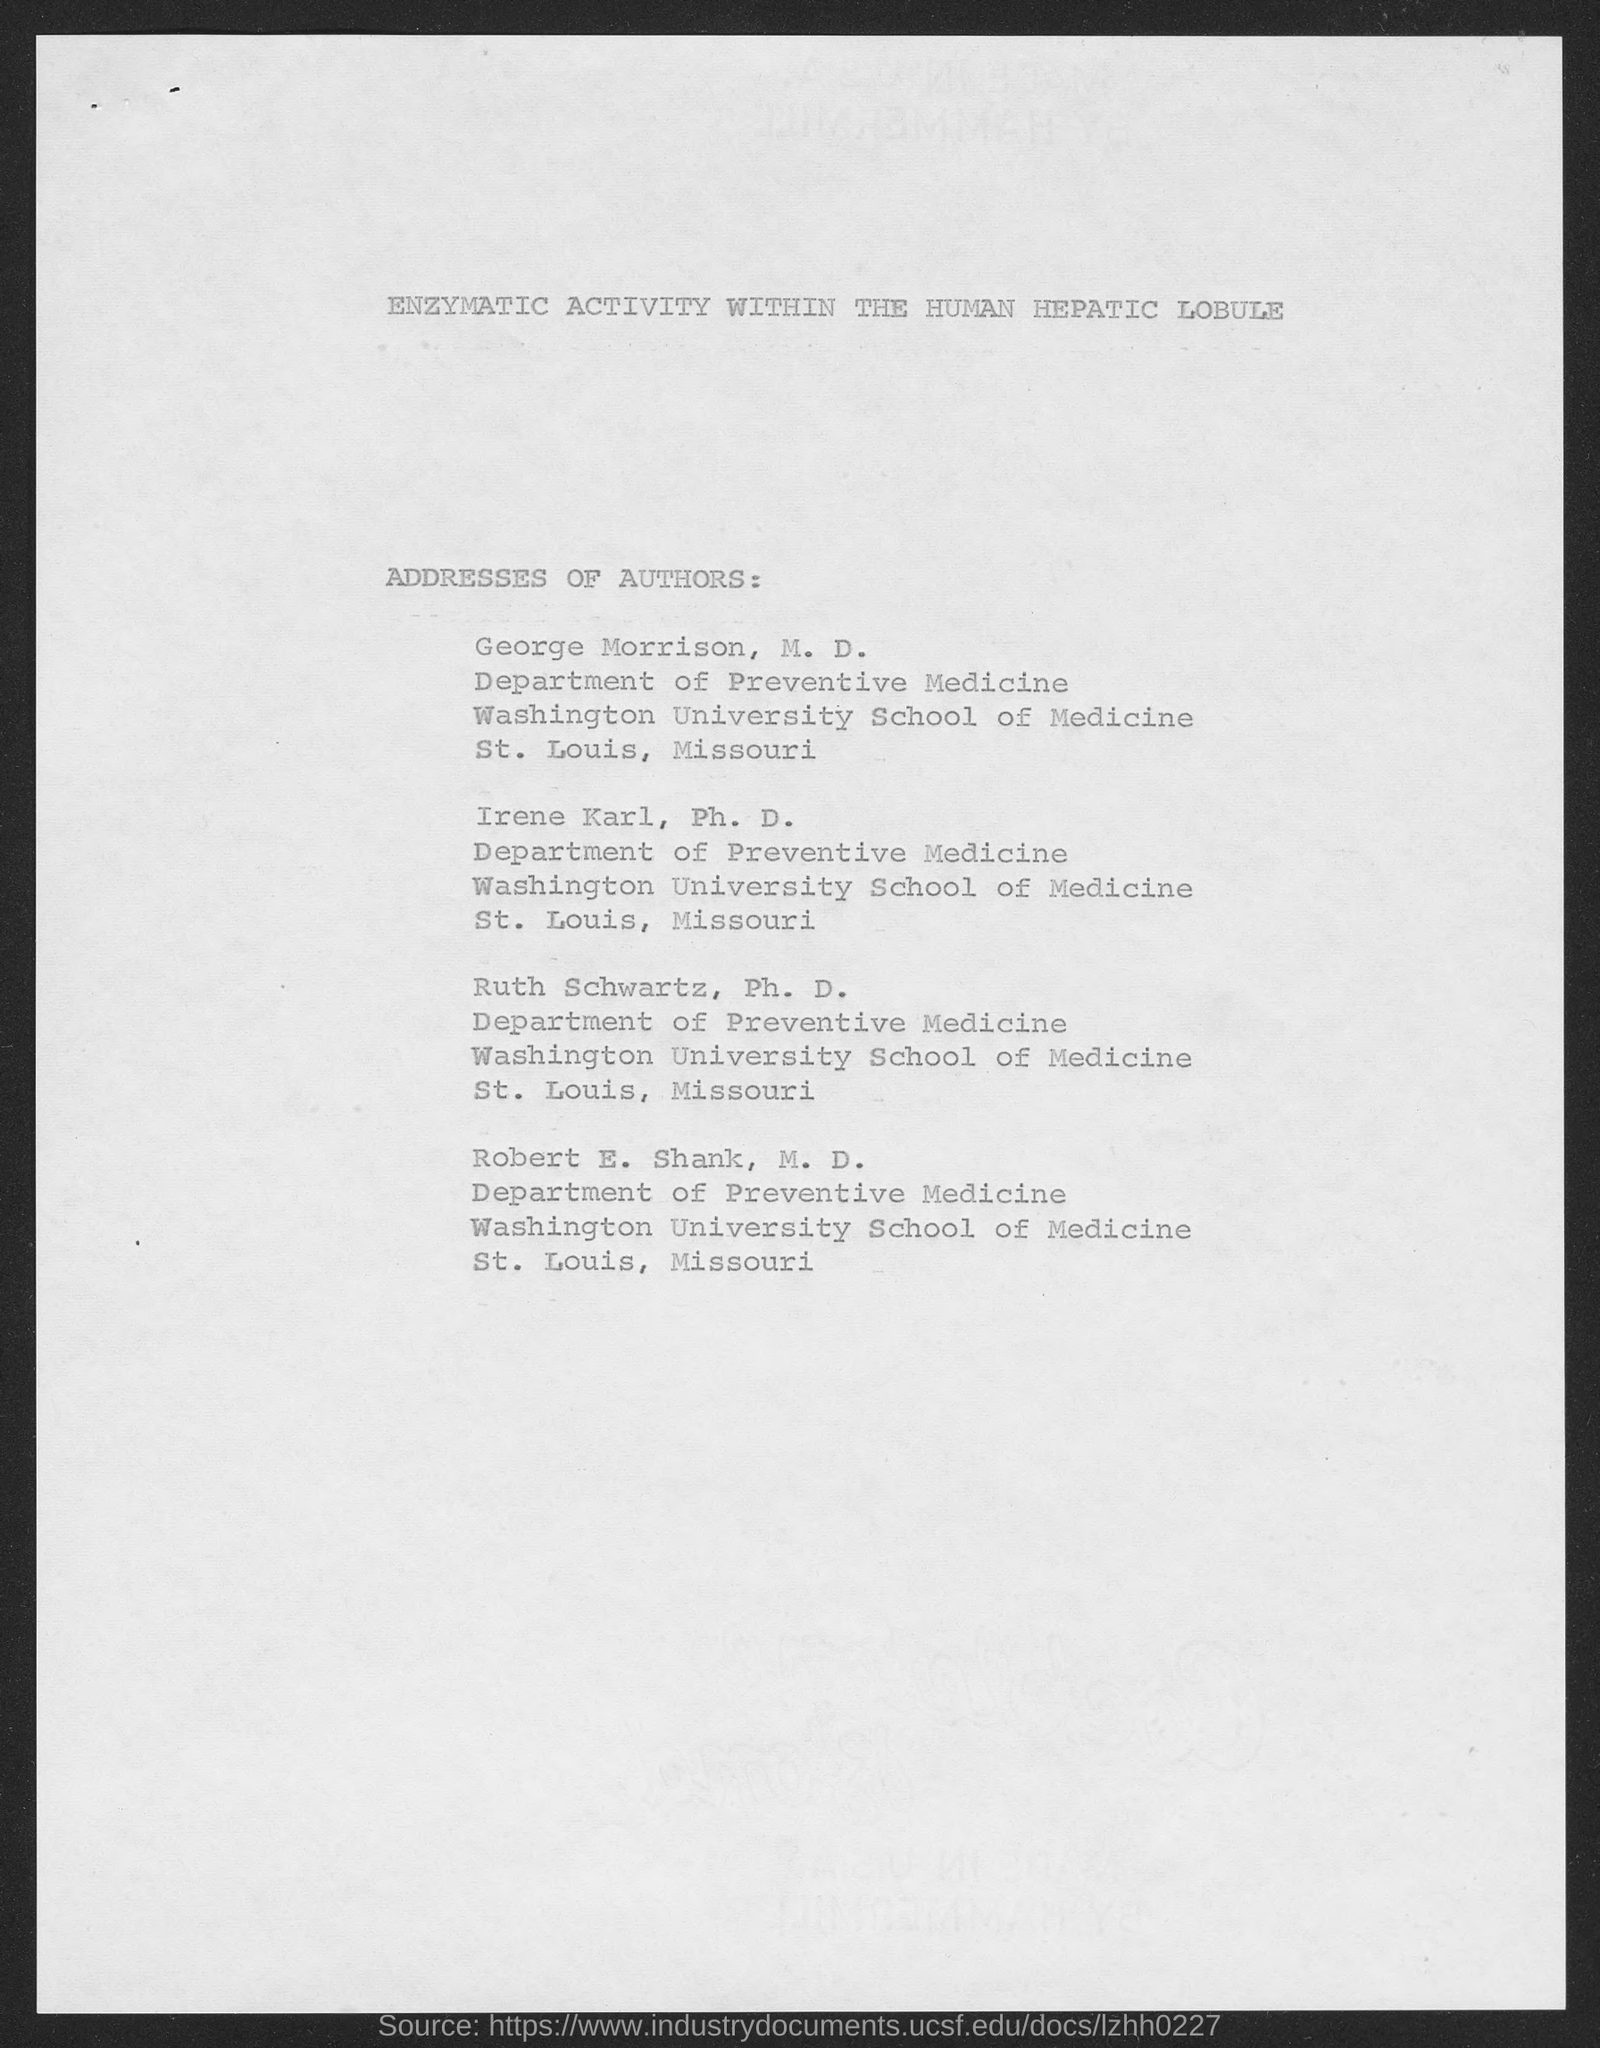Highlight a few significant elements in this photo. The title of the document is "Enzymatic Activity Within the Human Hepatic Lobule. 